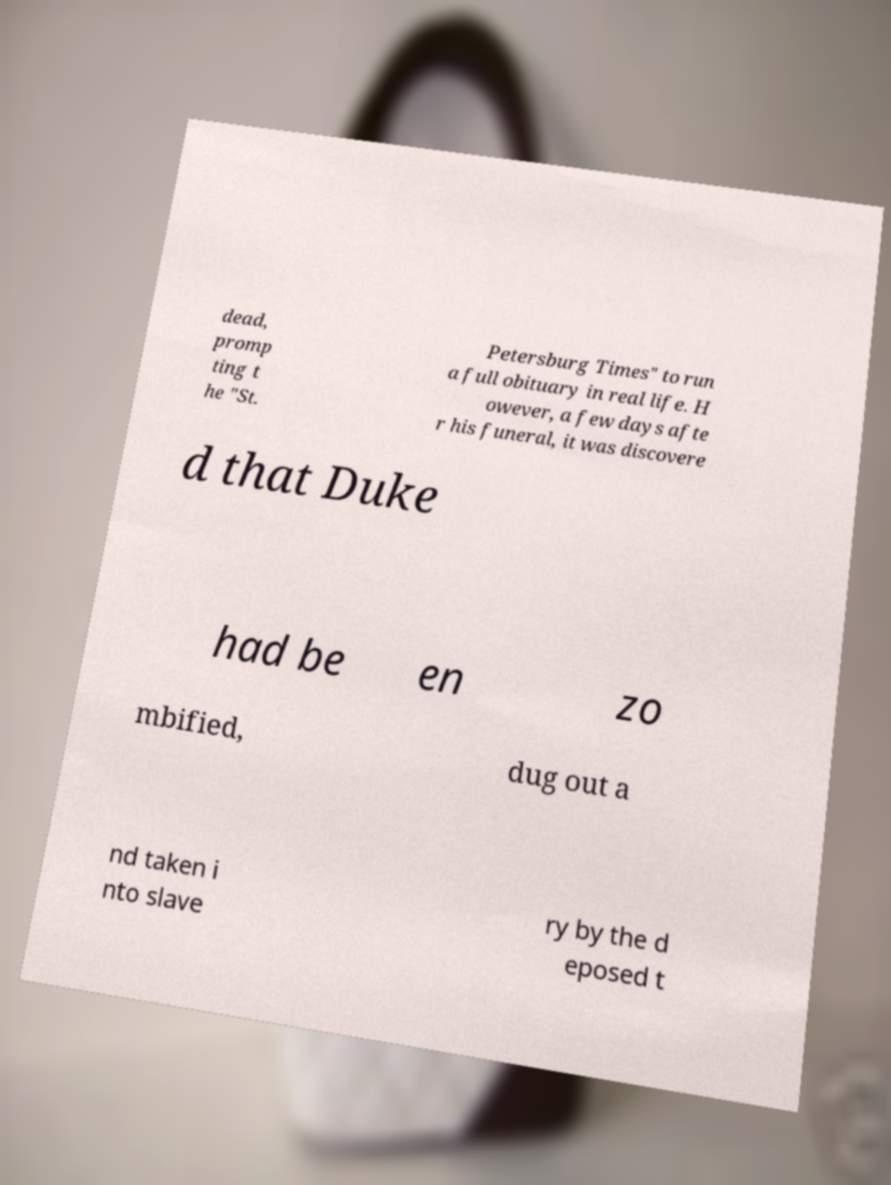I need the written content from this picture converted into text. Can you do that? dead, promp ting t he "St. Petersburg Times" to run a full obituary in real life. H owever, a few days afte r his funeral, it was discovere d that Duke had be en zo mbified, dug out a nd taken i nto slave ry by the d eposed t 